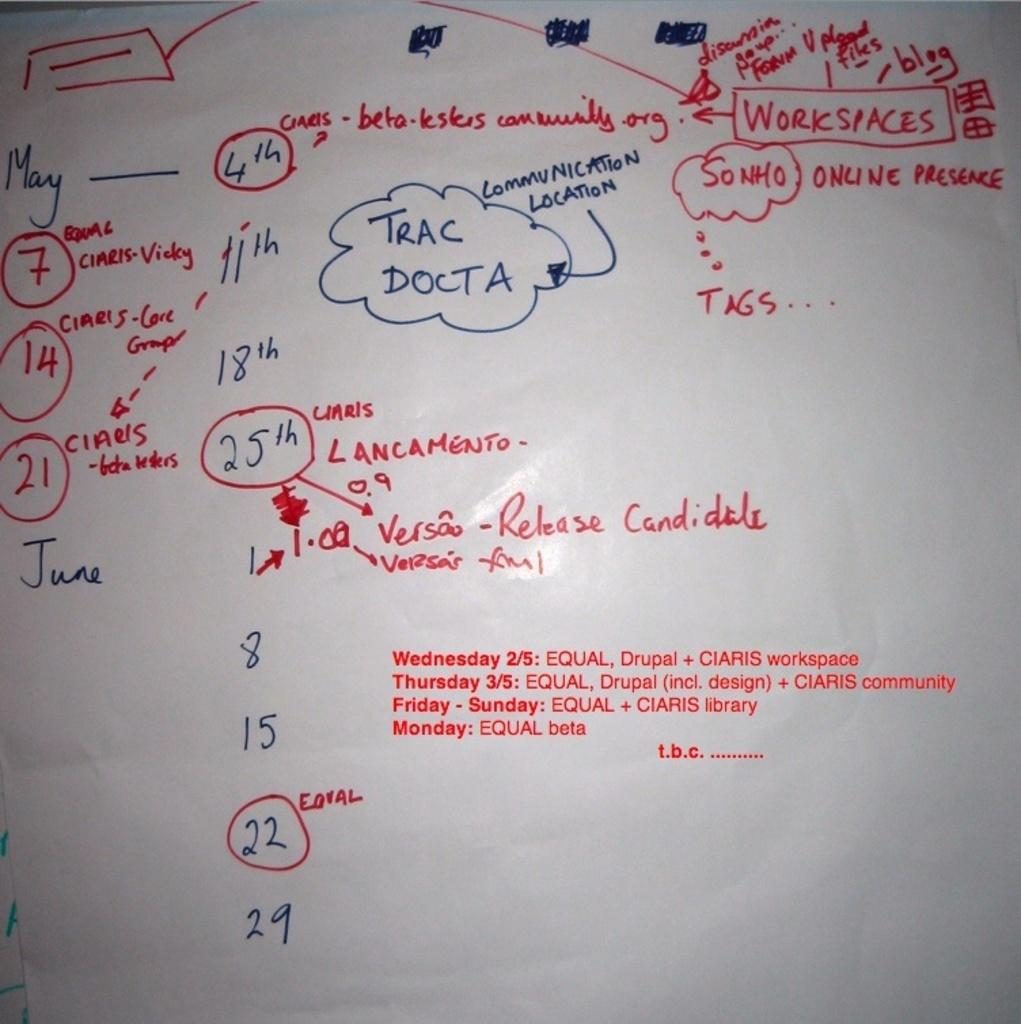<image>
Share a concise interpretation of the image provided. The Trac Docta is displayed on the white board 